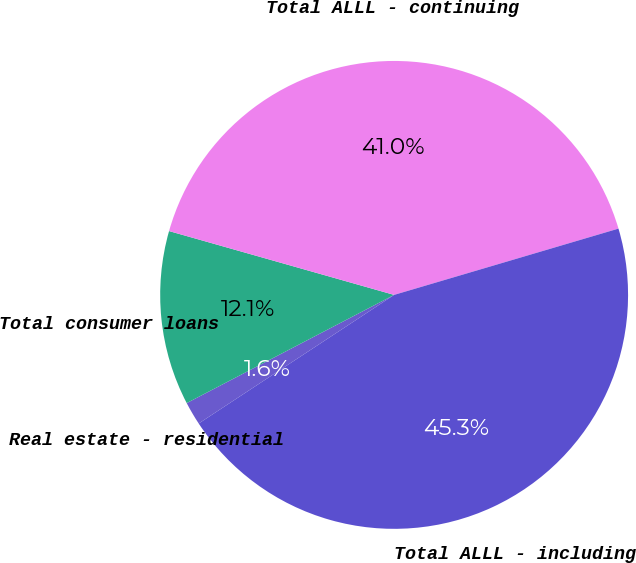Convert chart to OTSL. <chart><loc_0><loc_0><loc_500><loc_500><pie_chart><fcel>Real estate - residential<fcel>Total consumer loans<fcel>Total ALLL - continuing<fcel>Total ALLL - including<nl><fcel>1.61%<fcel>12.05%<fcel>41.03%<fcel>45.31%<nl></chart> 